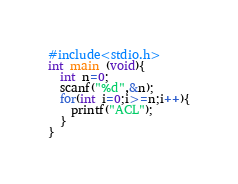Convert code to text. <code><loc_0><loc_0><loc_500><loc_500><_C_>#include<stdio.h>
int main (void){
  int n=0;
  scanf("%d",&n);
  for(int i=0;i>=n;i++){
    printf("ACL");
  }
}</code> 